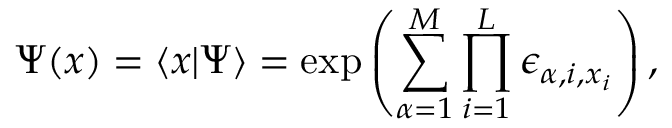<formula> <loc_0><loc_0><loc_500><loc_500>\Psi ( x ) = \langle x | \Psi \rangle = \exp \left ( \sum _ { \alpha = 1 } ^ { M } \prod _ { i = 1 } ^ { L } \epsilon _ { \alpha , i , x _ { i } } \right ) ,</formula> 